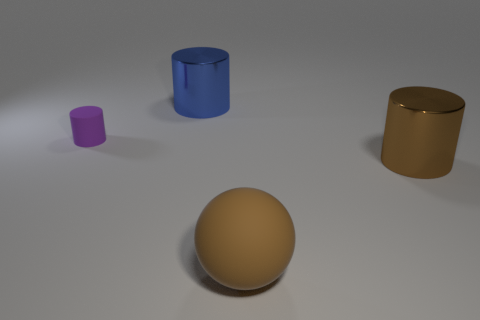Add 3 yellow shiny things. How many objects exist? 7 Subtract all cylinders. How many objects are left? 1 Add 1 big matte objects. How many big matte objects are left? 2 Add 4 rubber cylinders. How many rubber cylinders exist? 5 Subtract 1 blue cylinders. How many objects are left? 3 Subtract all brown rubber balls. Subtract all big metallic cylinders. How many objects are left? 1 